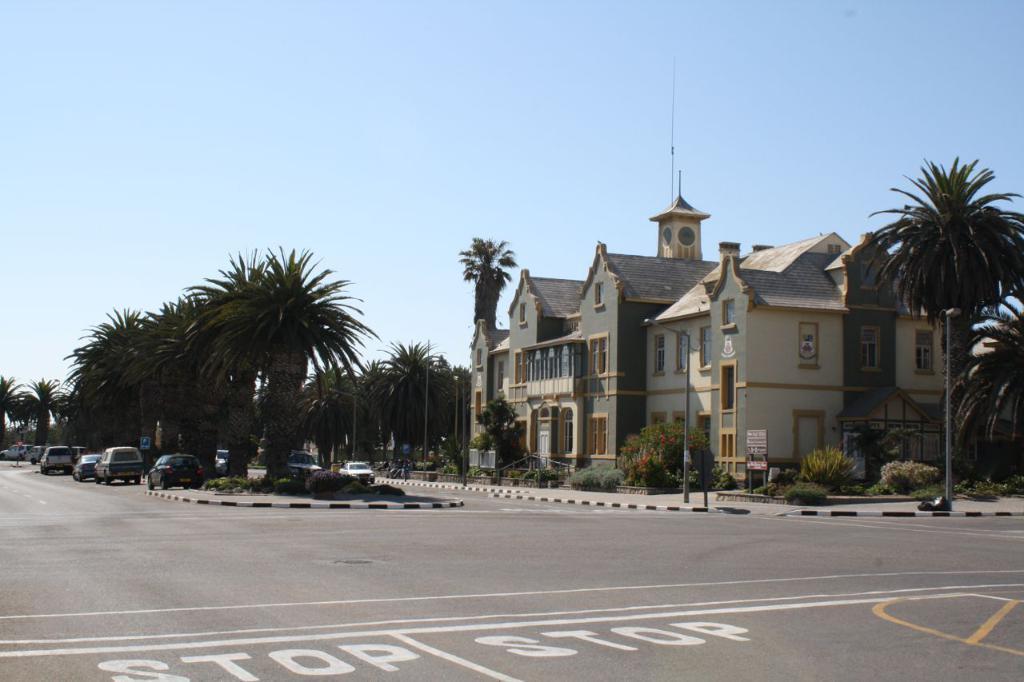Could you give a brief overview of what you see in this image? In this image, we can see a building in between trees. There are some cars on the road. In the background of the image, there is a sky. 